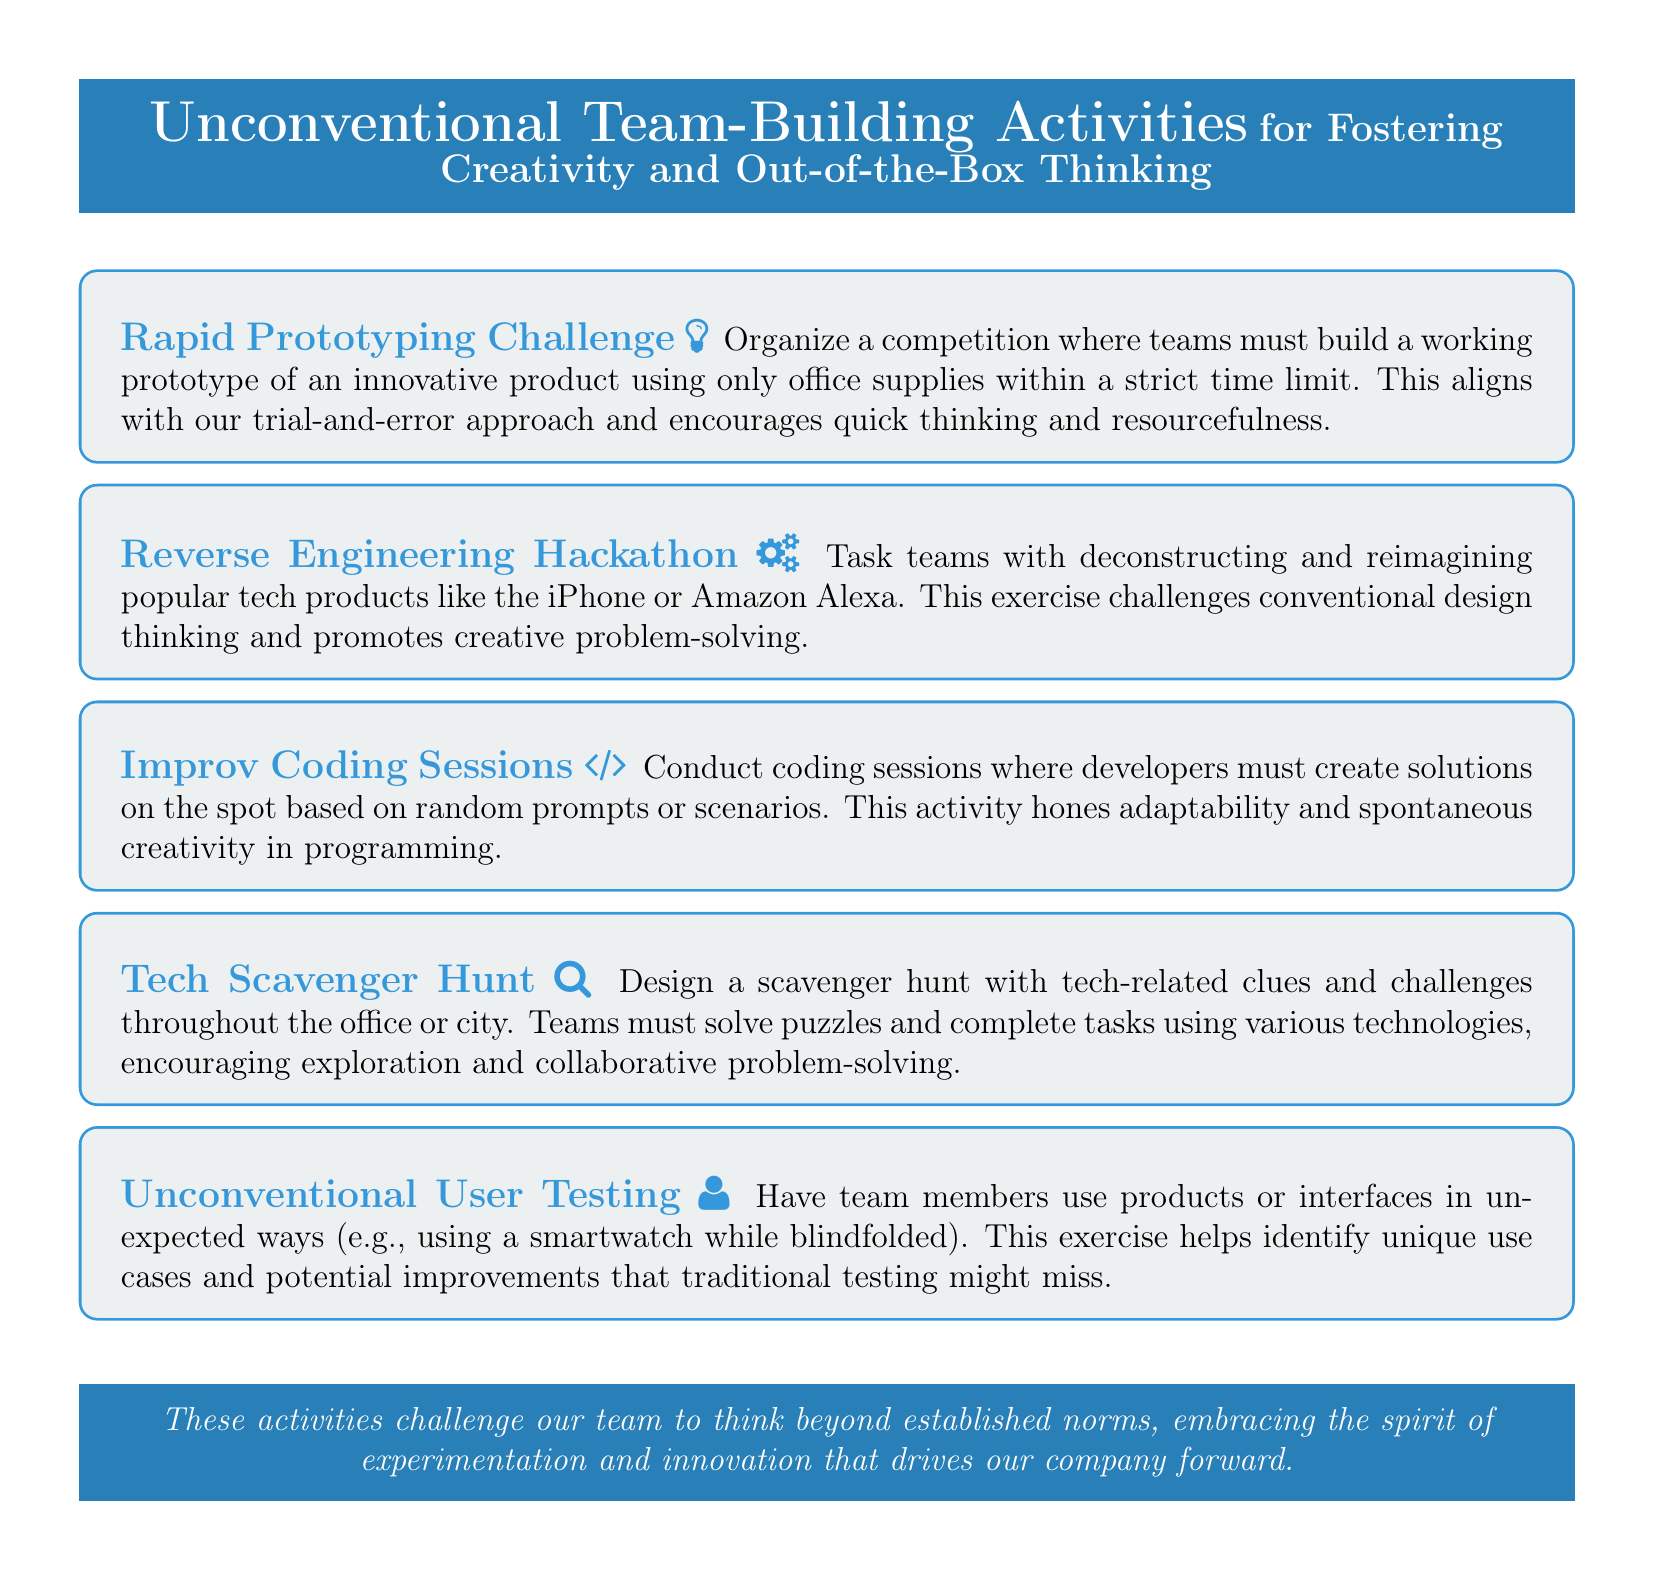What is the title of the document? The title is explicitly stated at the top of the document as "Unconventional Team-Building Activities for Fostering Creativity and Out-of-the-Box Thinking."
Answer: Unconventional Team-Building Activities for Fostering Creativity and Out-of-the-Box Thinking How many unconventional activities are listed? The document outlines a total of five unconventional activities under different headings.
Answer: Five What is the first activity mentioned? The first activity is clearly identified in the document, which starts with "Rapid Prototyping Challenge."
Answer: Rapid Prototyping Challenge What is the nature of the "Reverse Engineering Hackathon"? This activity is characterized by teams deconstructing and reimagining popular tech products, promoting a creative problem-solving approach.
Answer: Deconstructing popular tech products What unique method is used in "Unconventional User Testing"? The exercise encourages team members to use products in unexpected ways, which is described as a core part of this activity.
Answer: Unexpected ways How does the "Tech Scavenger Hunt" encourage collaboration? It specifies that teams must solve puzzles and complete tasks together, which inherently fosters collaborative problem-solving.
Answer: Solve puzzles and complete tasks collaboratively Which activity promotes adaptability in programming? This aspect of adaptability is emphasized in the content describing the "Improv Coding Sessions."
Answer: Improv Coding Sessions What common theme do these activities share? The central theme shared among the activities revolves around embracing experimentation and innovation in team building.
Answer: Embracing experimentation and innovation 